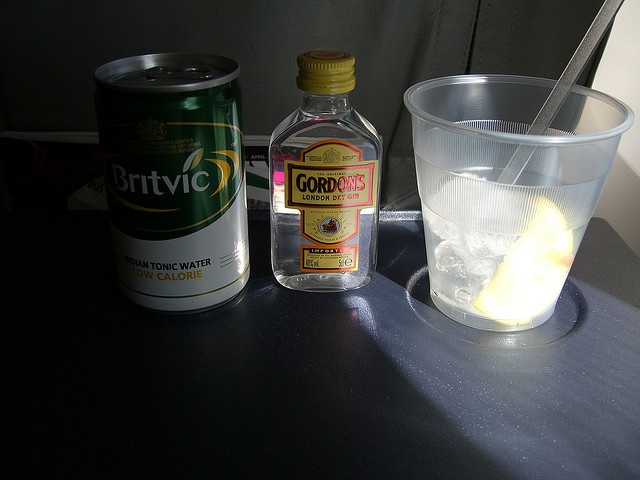Describe the objects in this image and their specific colors. I can see dining table in black, gray, ivory, and darkgray tones, cup in black, ivory, darkgray, and gray tones, and bottle in black, gray, olive, and tan tones in this image. 